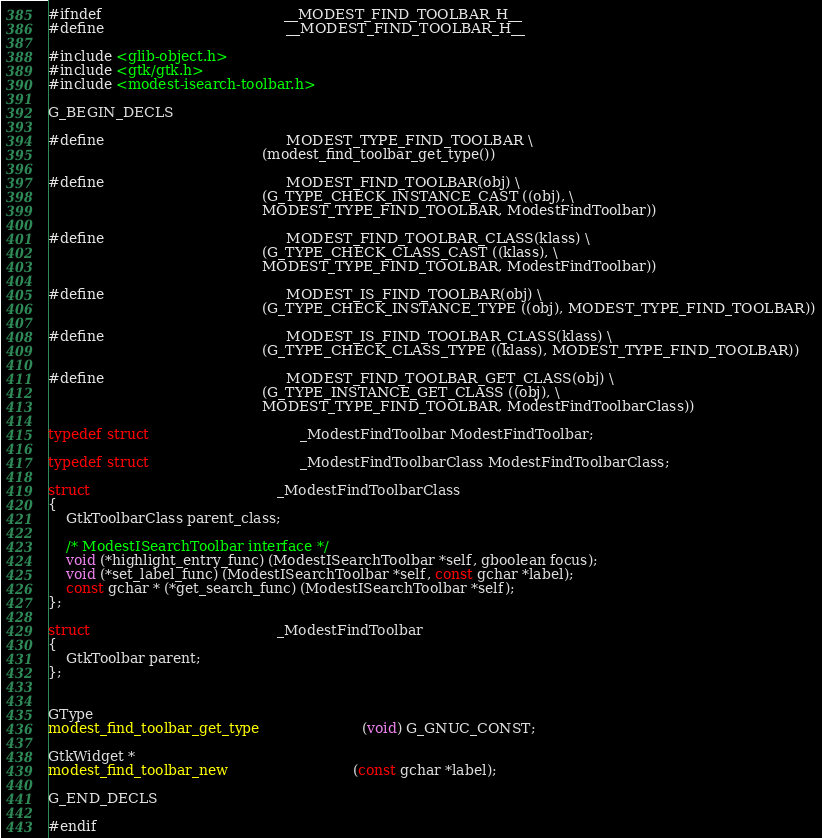Convert code to text. <code><loc_0><loc_0><loc_500><loc_500><_C_>#ifndef                                         __MODEST_FIND_TOOLBAR_H__
#define                                         __MODEST_FIND_TOOLBAR_H__

#include <glib-object.h>
#include <gtk/gtk.h>
#include <modest-isearch-toolbar.h>

G_BEGIN_DECLS

#define                                         MODEST_TYPE_FIND_TOOLBAR \
                                                (modest_find_toolbar_get_type())

#define                                         MODEST_FIND_TOOLBAR(obj) \
                                                (G_TYPE_CHECK_INSTANCE_CAST ((obj), \
                                                MODEST_TYPE_FIND_TOOLBAR, ModestFindToolbar))

#define                                         MODEST_FIND_TOOLBAR_CLASS(klass) \
                                                (G_TYPE_CHECK_CLASS_CAST ((klass), \
                                                MODEST_TYPE_FIND_TOOLBAR, ModestFindToolbar))

#define                                         MODEST_IS_FIND_TOOLBAR(obj) \
                                                (G_TYPE_CHECK_INSTANCE_TYPE ((obj), MODEST_TYPE_FIND_TOOLBAR))

#define                                         MODEST_IS_FIND_TOOLBAR_CLASS(klass) \
                                                (G_TYPE_CHECK_CLASS_TYPE ((klass), MODEST_TYPE_FIND_TOOLBAR))

#define                                         MODEST_FIND_TOOLBAR_GET_CLASS(obj) \
                                                (G_TYPE_INSTANCE_GET_CLASS ((obj), \
                                                MODEST_TYPE_FIND_TOOLBAR, ModestFindToolbarClass))

typedef struct                                  _ModestFindToolbar ModestFindToolbar;

typedef struct                                  _ModestFindToolbarClass ModestFindToolbarClass;

struct                                          _ModestFindToolbarClass
{
	GtkToolbarClass parent_class;

	/* ModestISearchToolbar interface */
	void (*highlight_entry_func) (ModestISearchToolbar *self, gboolean focus);
	void (*set_label_func) (ModestISearchToolbar *self, const gchar *label);
	const gchar * (*get_search_func) (ModestISearchToolbar *self);
};

struct                                          _ModestFindToolbar
{
	GtkToolbar parent;
};


GType
modest_find_toolbar_get_type                       (void) G_GNUC_CONST;

GtkWidget *
modest_find_toolbar_new                            (const gchar *label);

G_END_DECLS

#endif
</code> 